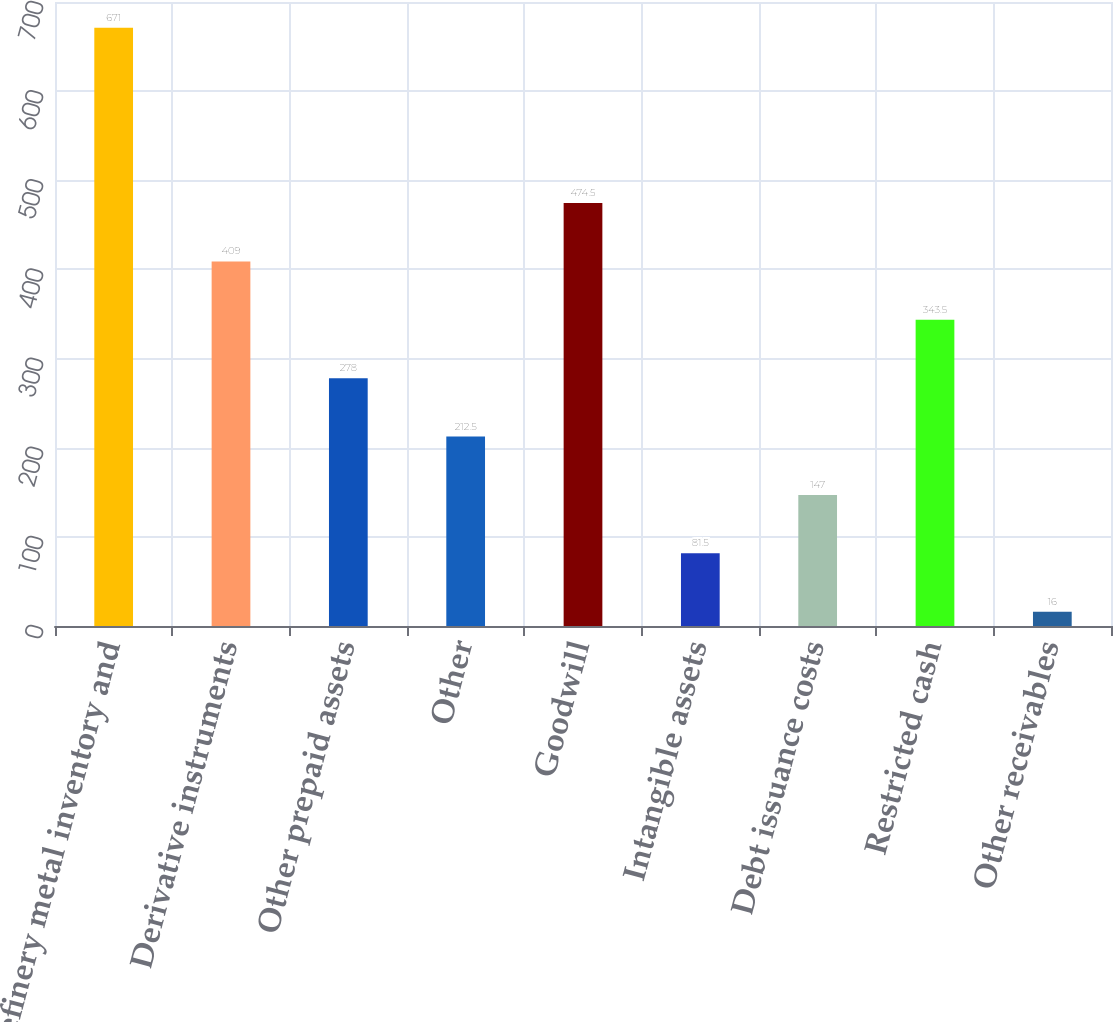Convert chart. <chart><loc_0><loc_0><loc_500><loc_500><bar_chart><fcel>Refinery metal inventory and<fcel>Derivative instruments<fcel>Other prepaid assets<fcel>Other<fcel>Goodwill<fcel>Intangible assets<fcel>Debt issuance costs<fcel>Restricted cash<fcel>Other receivables<nl><fcel>671<fcel>409<fcel>278<fcel>212.5<fcel>474.5<fcel>81.5<fcel>147<fcel>343.5<fcel>16<nl></chart> 